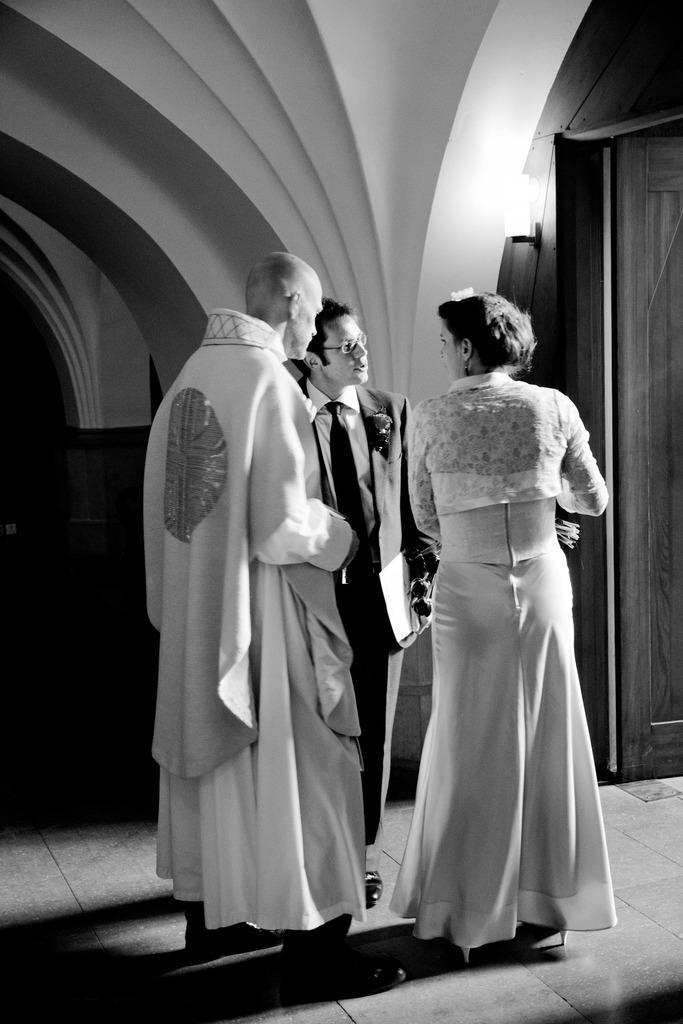Could you give a brief overview of what you see in this image? In this picture we can see a woman and two men, the middle person is holding a file, in front of them we can see a light and it is a black and white photography. 